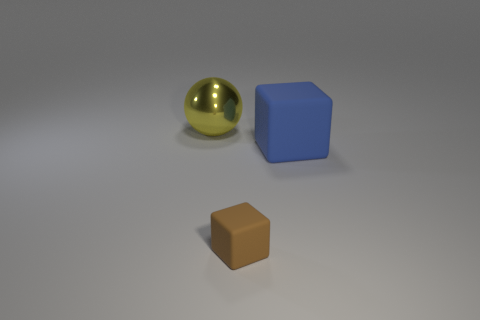There is a matte block in front of the blue object; what size is it?
Provide a succinct answer. Small. Does the brown object have the same material as the large object to the left of the big matte cube?
Make the answer very short. No. What number of tiny objects are blue objects or rubber cubes?
Provide a short and direct response. 1. Are there fewer big yellow shiny objects than things?
Provide a succinct answer. Yes. Is the size of the rubber thing that is behind the small brown matte object the same as the cube that is left of the big cube?
Offer a very short reply. No. How many gray objects are large blocks or metal things?
Give a very brief answer. 0. Are there more brown matte cubes than cyan cylinders?
Your answer should be compact. Yes. How many things are big yellow objects or yellow shiny balls behind the brown cube?
Your answer should be compact. 1. How many other objects are the same shape as the big yellow object?
Provide a short and direct response. 0. Is the number of brown rubber cubes that are in front of the metal ball less than the number of objects on the left side of the large rubber block?
Your answer should be compact. Yes. 